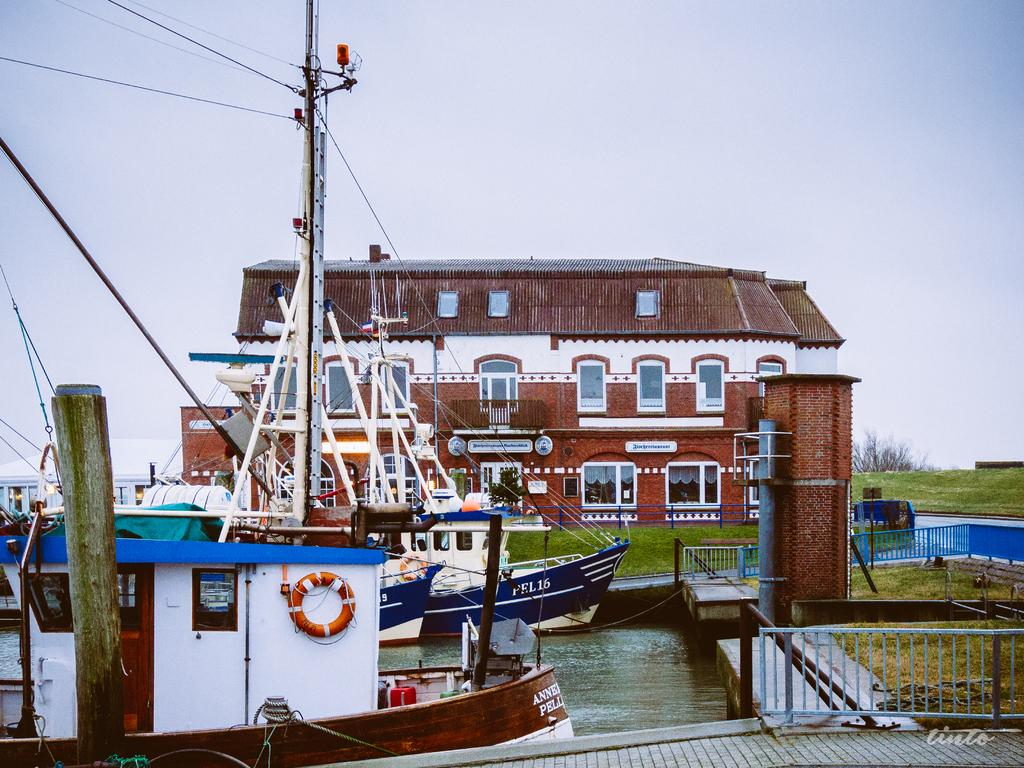What is in the water in the image? There are boats in the water in the image. What can be seen in the background of the image? There is a building and greenery ground in the background of the image. What type of glass can be seen in the image? There is no glass present in the image; it features boats in the water and a building and greenery ground in the background. 